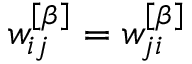Convert formula to latex. <formula><loc_0><loc_0><loc_500><loc_500>w _ { i j } ^ { \left [ \beta \right ] } = w _ { j i } ^ { \left [ \beta \right ] }</formula> 